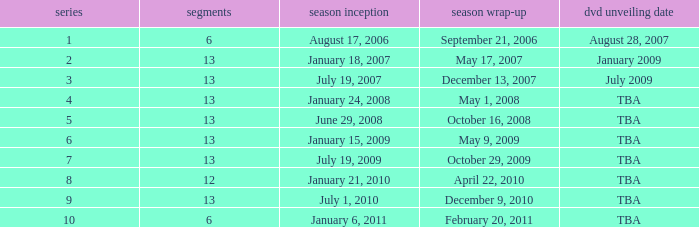Which season had fewer than 13 episodes and aired its season finale on February 20, 2011? 1.0. 